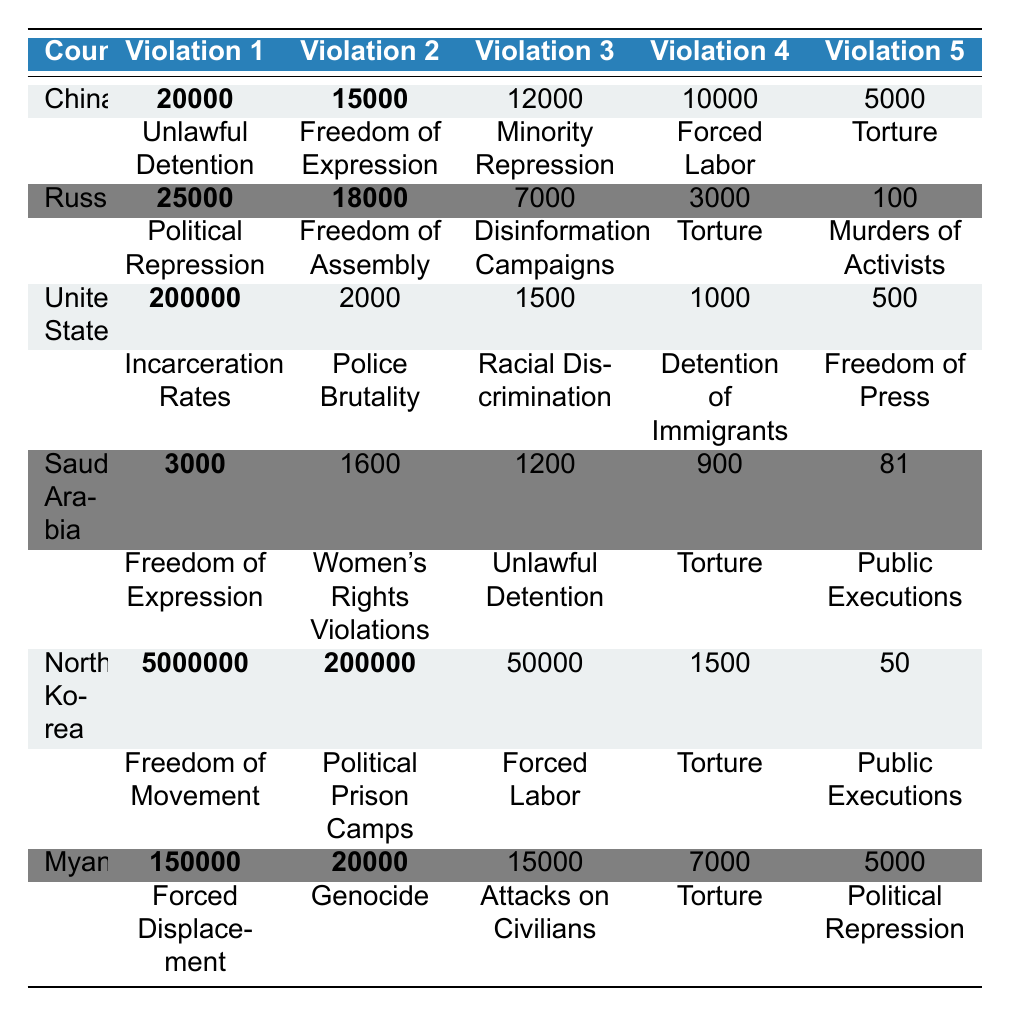What country had the highest number of torture violations? By examining the table, we can see that China had the highest number of torture violations with 5000 cases.
Answer: China Which violation in North Korea had the highest count? The table shows that the highest violation count in North Korea is for Freedom of Movement with 5000000 cases.
Answer: Freedom of Movement What is the total number of violations reported for Myanmar? To find the total, we sum all violations in Myanmar: 150000 (Forced Displacement) + 20000 (Genocide) + 15000 (Attacks on Civilians) + 7000 (Torture) + 5000 (Political Repression) = 200000.
Answer: 200000 Is the number of political repression violations in Russia greater than the number of torture violations in Saudi Arabia? The number of political repression violations in Russia is 25000, while torture violations in Saudi Arabia are 900. Since 25000 is greater than 900, the statement is true.
Answer: Yes What was the difference in the number of unlawful detentions between China and Saudi Arabia? The number of unlawful detentions in China is 20000 and in Saudi Arabia is 1200. The difference is 20000 - 1200 = 18800.
Answer: 18800 What is the total number of violations across all listed countries? We sum all the violations for each country: China (20000 + 15000 + 12000 + 10000 + 5000 = 62000), Russia (25000 + 18000 + 7000 + 3000 + 100 = 50000), United States (200000 + 2000 + 1500 + 1000 + 500 = 203000), Saudi Arabia (3000 + 1600 + 1200 + 900 + 81 = 5881), North Korea (5000000 + 200000 + 50000 + 1500 + 50 = 5200000), Myanmar (150000 + 20000 + 15000 + 7000 + 5000 = 200000). Total is 62000 + 50000 + 203000 + 5881 + 5200000 + 200000 = 5785881.
Answer: 5785881 Which violation type has the lowest count in the United States? By inspecting the table, we can see that Freedom of Press has the lowest count in the United States with 500 cases.
Answer: Freedom of Press Which country has the highest number for forced labor violations? The table indicates that North Korea has the highest number for forced labor violations, which is 50000 cases.
Answer: North Korea Is the total number of violations for China more than the total for the United States? The total number of violations in China is 62000, and for the United States, it is 203000. Since 62000 is less than 203000, the statement is false.
Answer: No What is the average number of violations for North Korea? To find the average, we sum the violations for North Korea: 5000000 + 200000 + 50000 + 1500 + 50 = 5200000. There are 5 types of violations, so the average is 5200000 / 5 = 1040000.
Answer: 1040000 